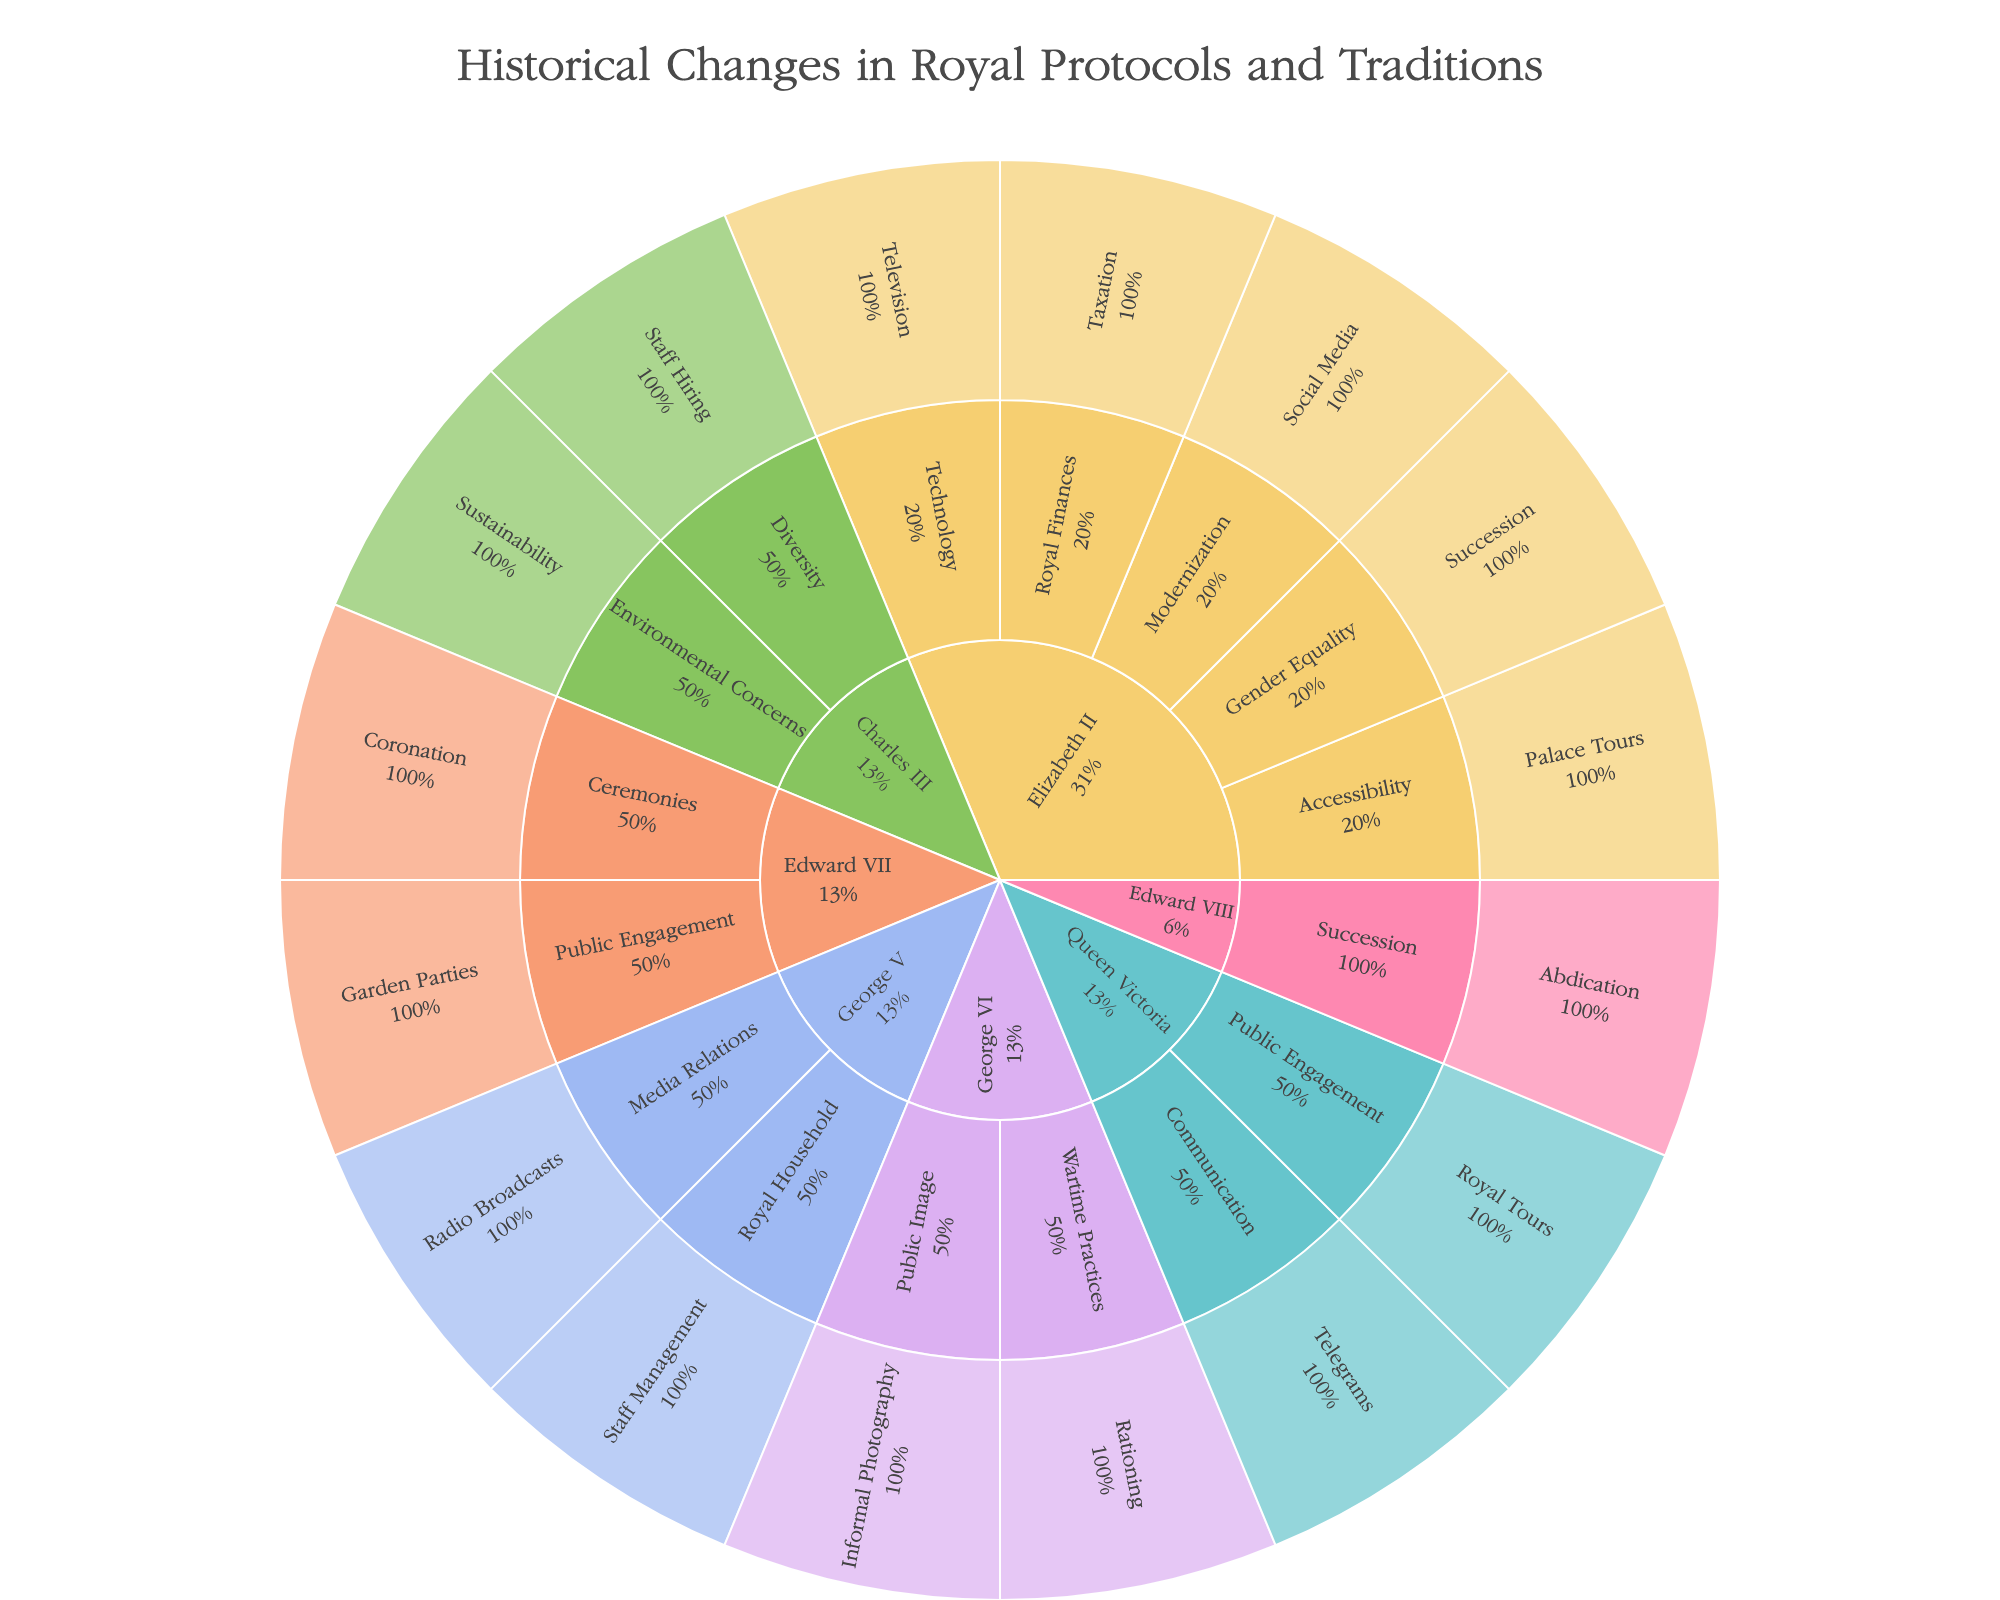What is the title of the plot? The title of the plot is usually found at the top. In this case, the title is "Historical Changes in Royal Protocols and Traditions.”
Answer: Historical Changes in Royal Protocols and Traditions How many categories of traditions are displayed for Queen Victoria? Look at the Queen Victoria section and count the distinct categories linked to her. There are two categories: Public Engagement and Communication.
Answer: 2 Which monarch introduced the first Christmas radio broadcast? Identify the "Radio Broadcasts" tradition and see which monarch it is associated with. It is under George V.
Answer: George V What change is associated with the abdication process? Find the "Succession" category linked with "Abdication" and look at the hover data to see the change. The change is "Introduction of abdication process."
Answer: Introduction of abdication process Which monarch implemented sustainable practices in royal estates? Trace the category and tradition related to sustainability. It falls under "Environmental Concerns" and "Sustainability" for Charles III.
Answer: Charles III Which monarch's reign features the most changes listed in this plot? Count the number of changes under each monarch’s reign by looking at their segments in the sunburst plot. Elizabeth II has the most changes listed.
Answer: Elizabeth II How many technological advancements are introduced according to the plot, and which monarchs are involved? Identify all technological advancements such as "Telegrams" and "Television," then count them and note the involved monarchs. Telegrams (Queen Victoria) and Television (Elizabeth II) gives 2 advancements.
Answer: 2, Queen Victoria and Elizabeth II Between Edward VII and George VI, who made more changes in the area of Public Engagement? Compare the number of changes under the "Public Engagement" category for both monarchs. Edward VII has 1 (Garden Parties), and George VI has none.
Answer: Edward VII Which category under Elizabeth II includes the most changes? Look at the number of traditions listed for each category under Elizabeth II. "Modernization" includes "Social Media," which is the only tradition in that category. Thus, each category has an equal number (one) of changes for Elizabeth II.
Answer: All categories have an equal number of changes What modern communicative change did Queen Victoria introduce? Locate the tradition under the "Communication" category for Queen Victoria. She introduced telegrams for royal communication.
Answer: Adoption of telegrams for royal communication 